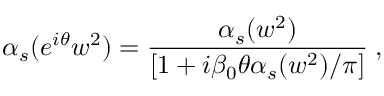<formula> <loc_0><loc_0><loc_500><loc_500>{ \alpha } _ { s } ( { e } ^ { i { \theta } } w ^ { 2 } ) = \frac { { \alpha } _ { s } ( w ^ { 2 } ) } { [ 1 + i { \beta } _ { 0 } { \theta } { \alpha } _ { s } ( w ^ { 2 } ) / { \pi } ] } \, ,</formula> 